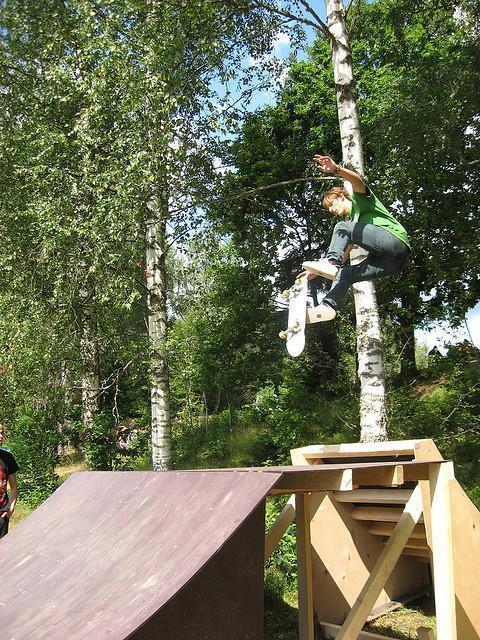What is this large contraption called?
Pick the right solution, then justify: 'Answer: answer
Rationale: rationale.'
Options: Skateboarding ramp, shed, roof, slope. Answer: skateboarding ramp.
Rationale: The ramp is sloped so people can go down it with a skateboard. 